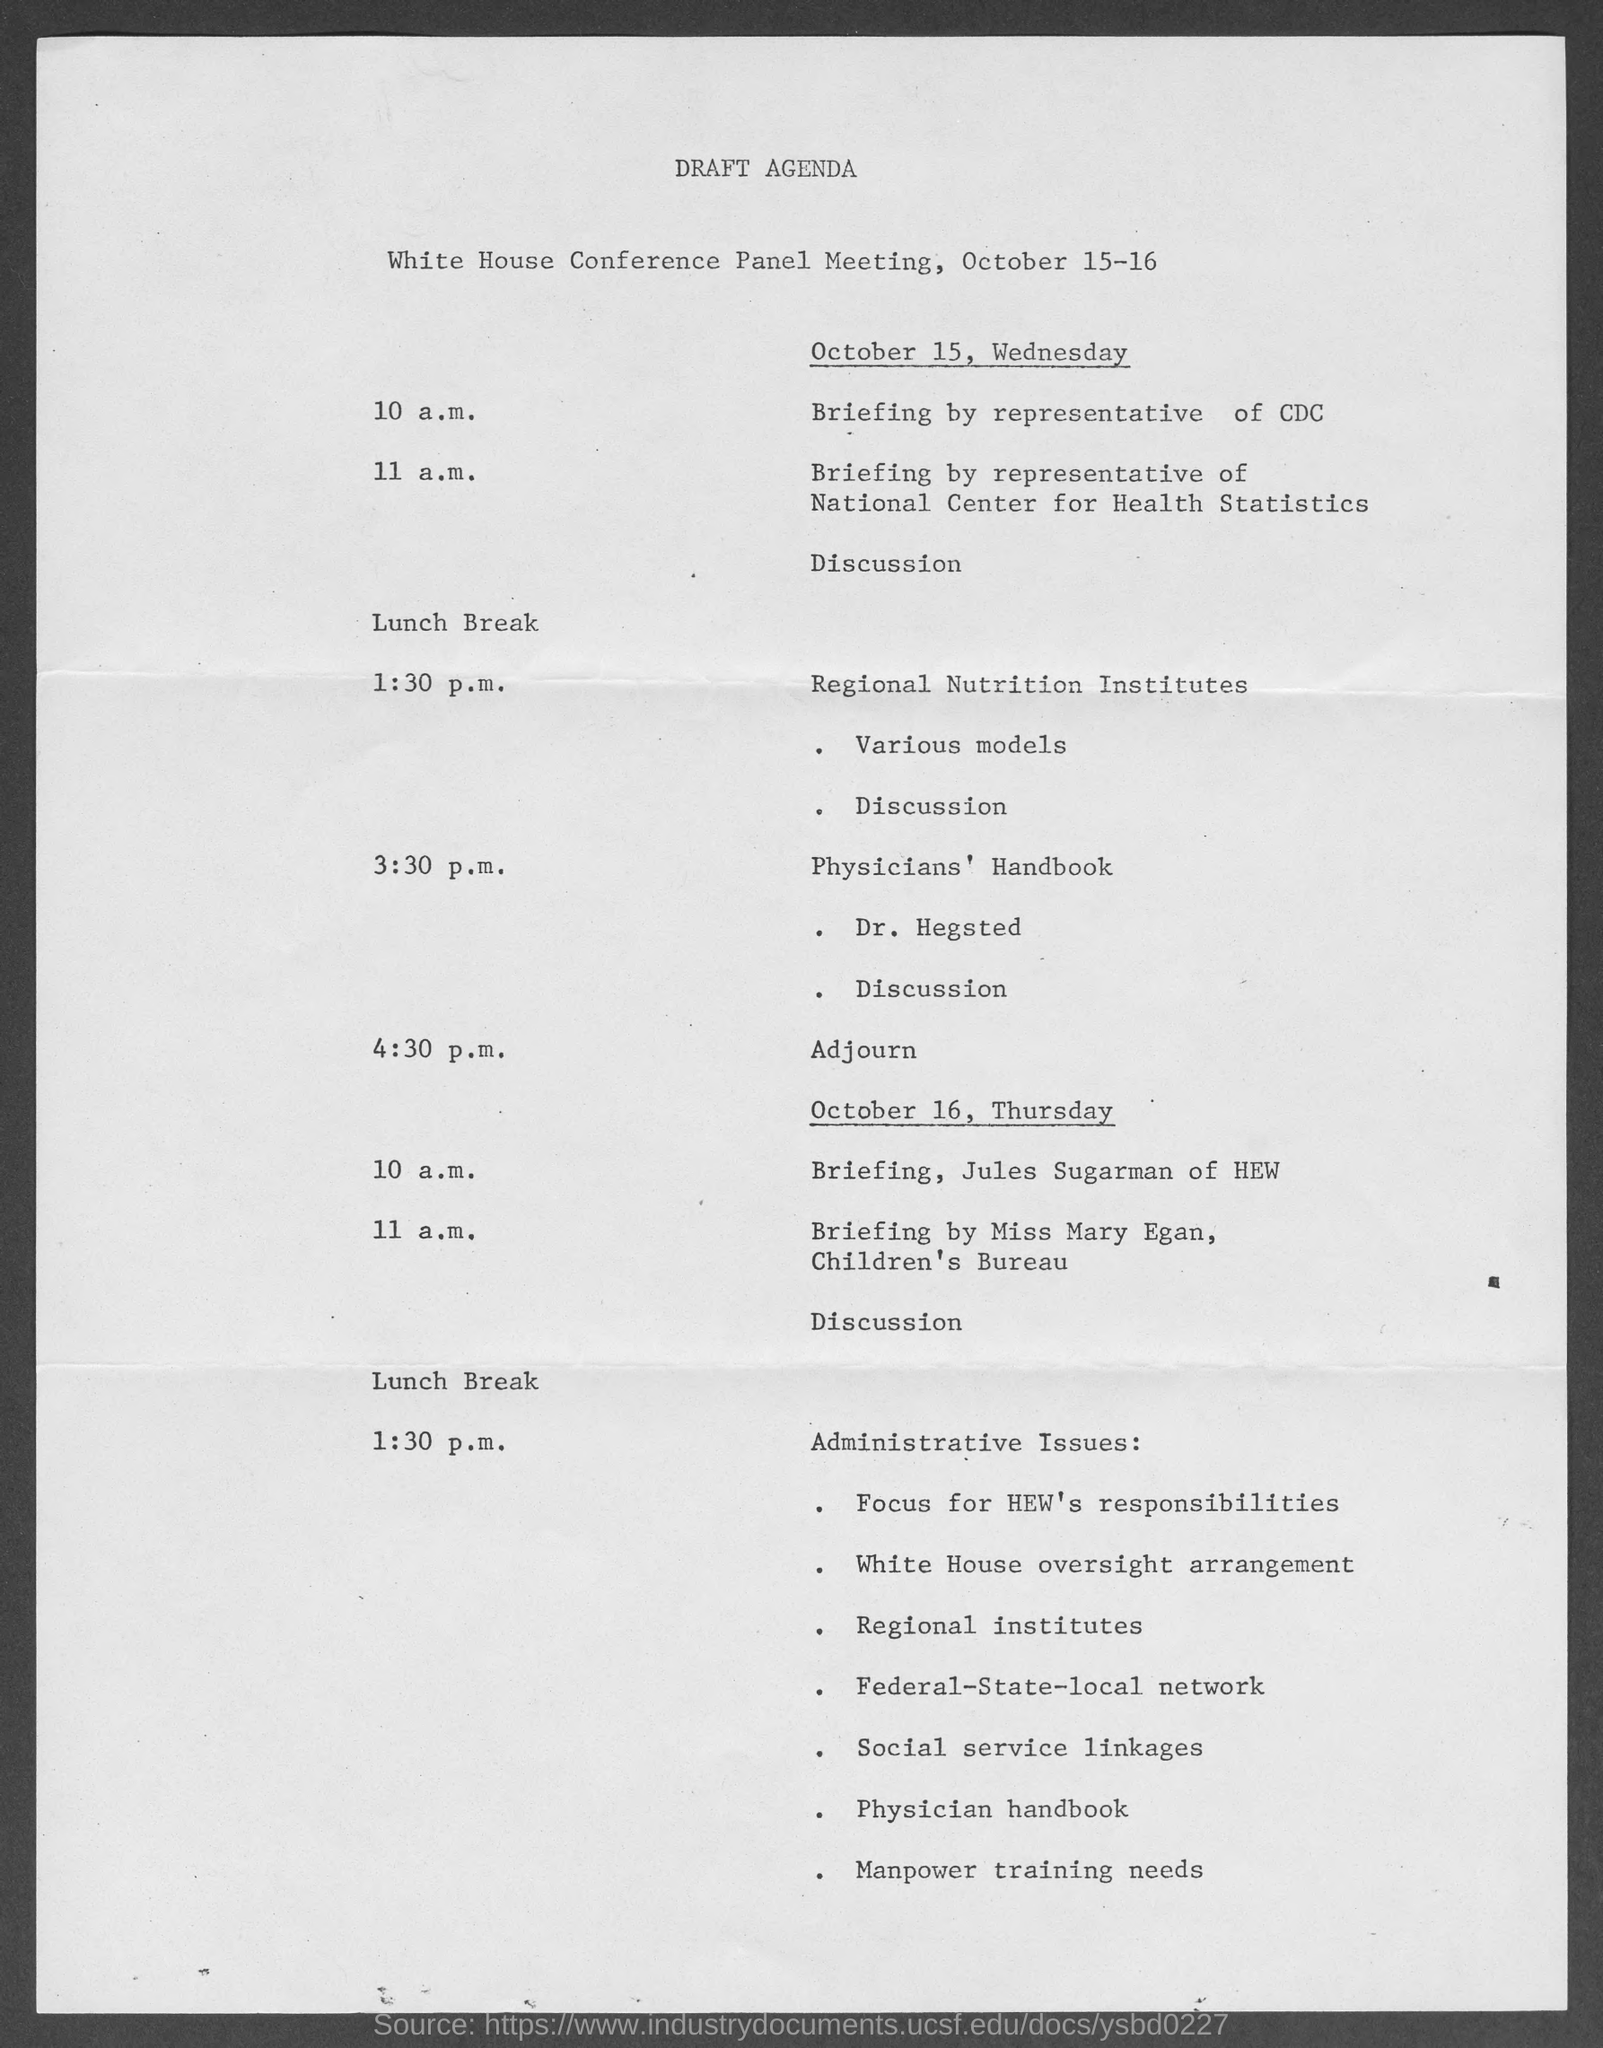List a handful of essential elements in this visual. The document title is a draft agenda. The meeting will be held on October 15-16. The Physicians' Handbook is being discussed by Dr. Hegsted. On October 15, there will be a briefing by a representative of the Centers for Disease Control and Prevention (CDC) at 10 a.m. On October 16 at 11 a.m., there will be a briefing by Miss Mary Egan of the Children's Bureau. 